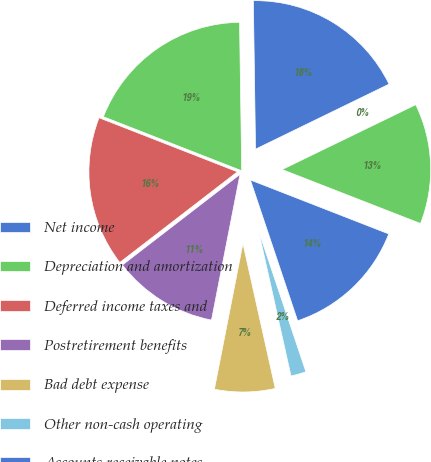<chart> <loc_0><loc_0><loc_500><loc_500><pie_chart><fcel>Net income<fcel>Depreciation and amortization<fcel>Deferred income taxes and<fcel>Postretirement benefits<fcel>Bad debt expense<fcel>Other non-cash operating<fcel>Accounts receivable notes<fcel>Inventories<fcel>Accounts payable<nl><fcel>18.02%<fcel>18.84%<fcel>16.38%<fcel>11.47%<fcel>6.57%<fcel>1.66%<fcel>13.93%<fcel>13.11%<fcel>0.02%<nl></chart> 